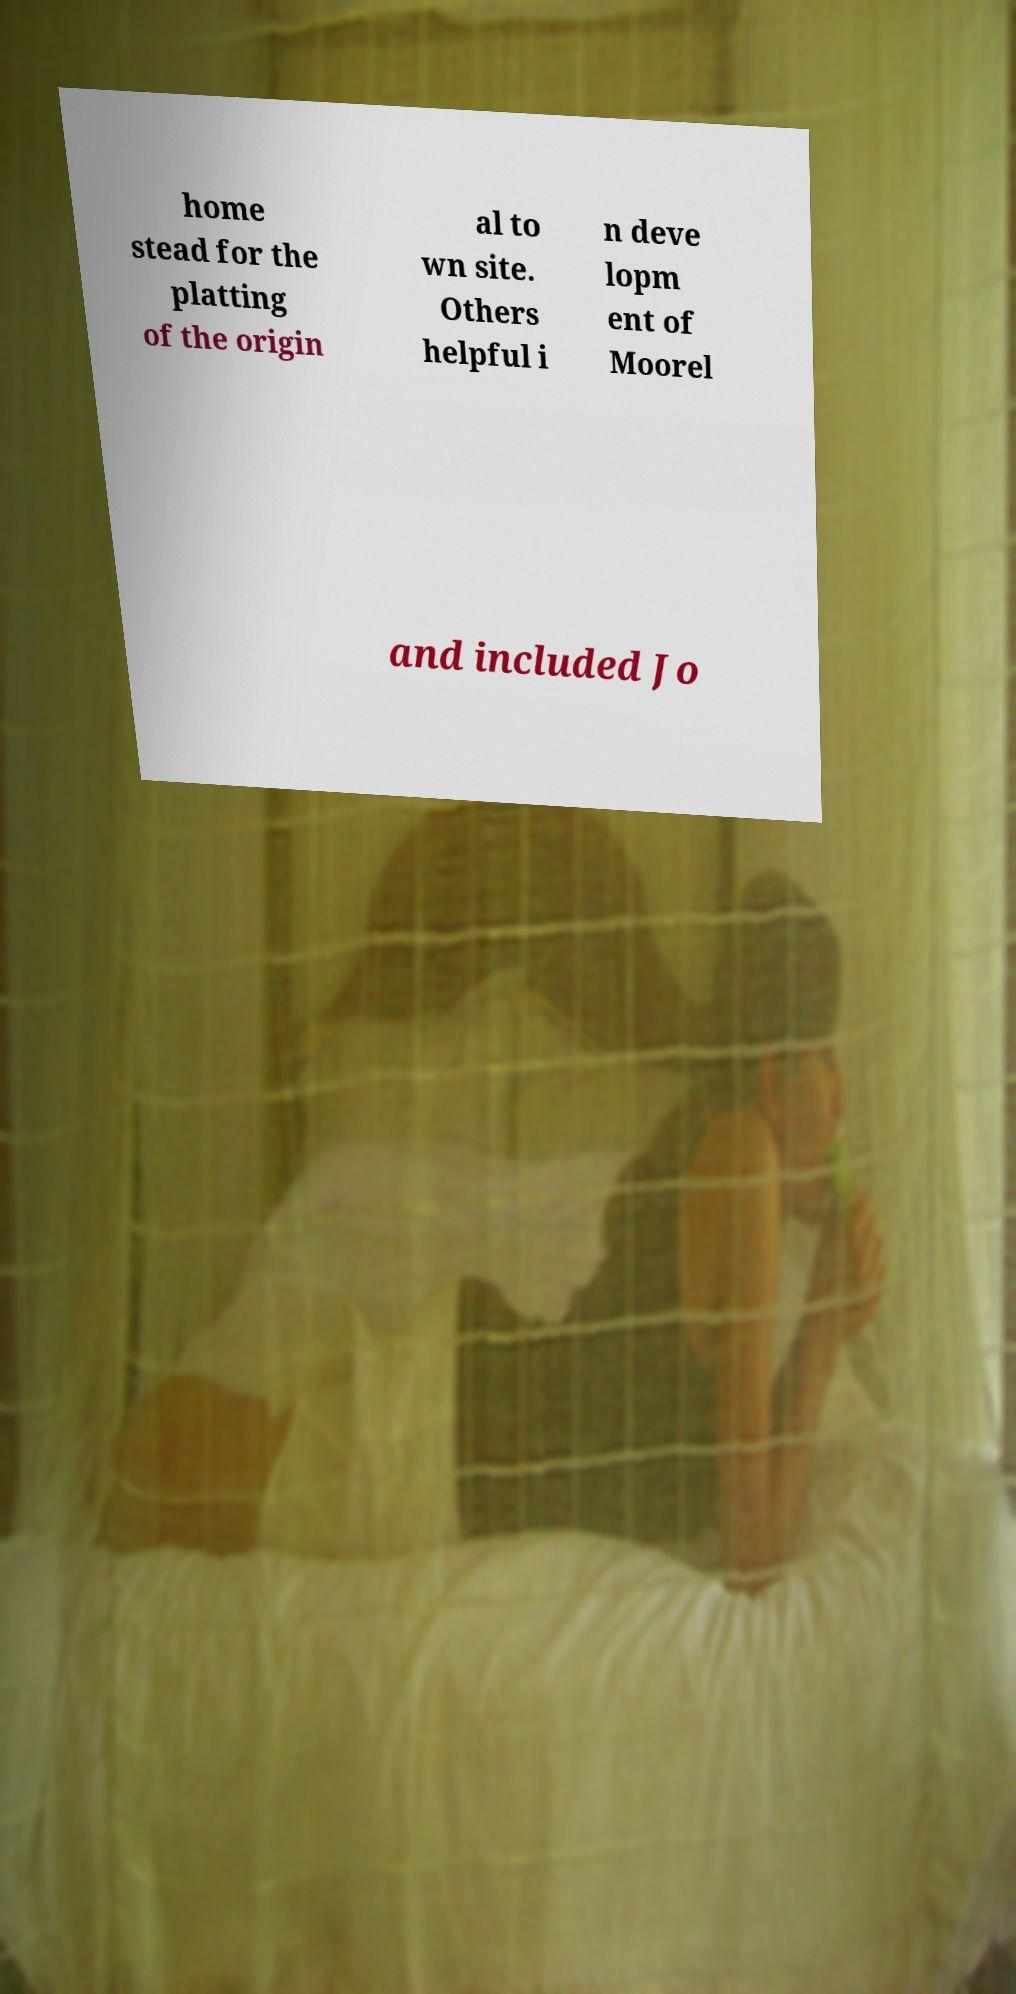Please read and relay the text visible in this image. What does it say? home stead for the platting of the origin al to wn site. Others helpful i n deve lopm ent of Moorel and included Jo 